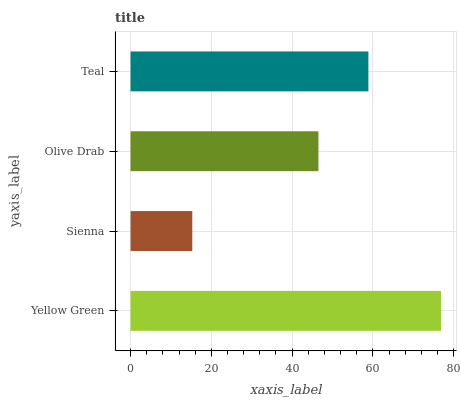Is Sienna the minimum?
Answer yes or no. Yes. Is Yellow Green the maximum?
Answer yes or no. Yes. Is Olive Drab the minimum?
Answer yes or no. No. Is Olive Drab the maximum?
Answer yes or no. No. Is Olive Drab greater than Sienna?
Answer yes or no. Yes. Is Sienna less than Olive Drab?
Answer yes or no. Yes. Is Sienna greater than Olive Drab?
Answer yes or no. No. Is Olive Drab less than Sienna?
Answer yes or no. No. Is Teal the high median?
Answer yes or no. Yes. Is Olive Drab the low median?
Answer yes or no. Yes. Is Olive Drab the high median?
Answer yes or no. No. Is Teal the low median?
Answer yes or no. No. 